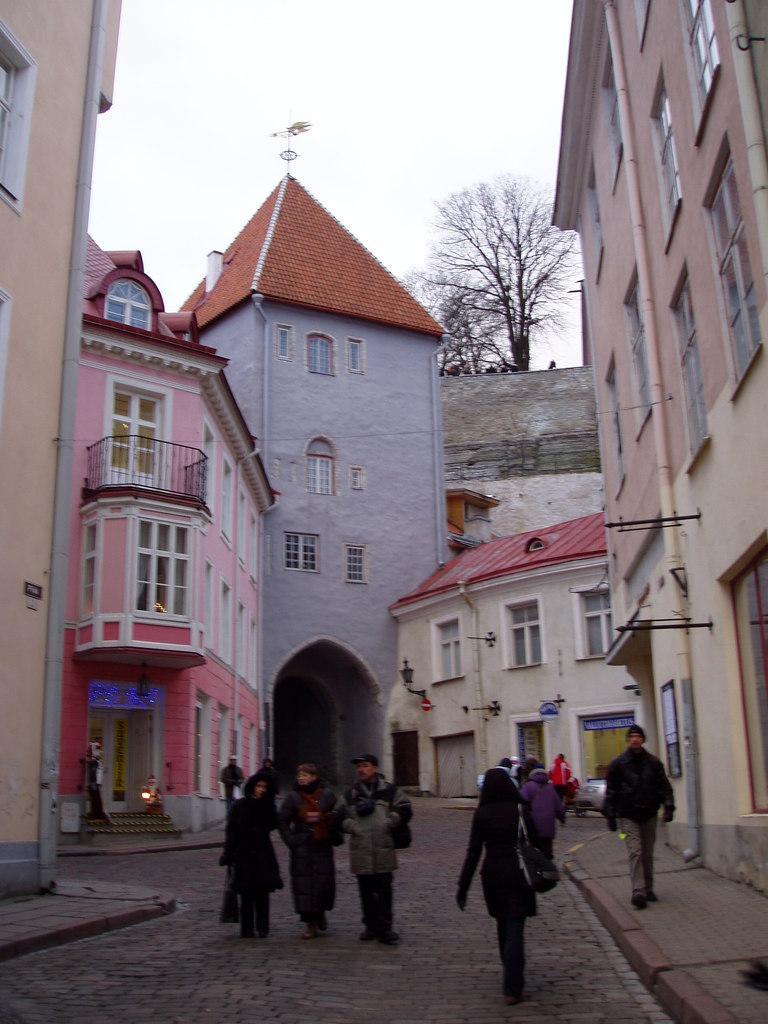How would you summarize this image in a sentence or two? In this picture we can see some people walking at the bottom, in the background there are some buildings, we can see a light on the left side, there is the sky and a tree at the top of the picture, we can see windows of these buildings. 